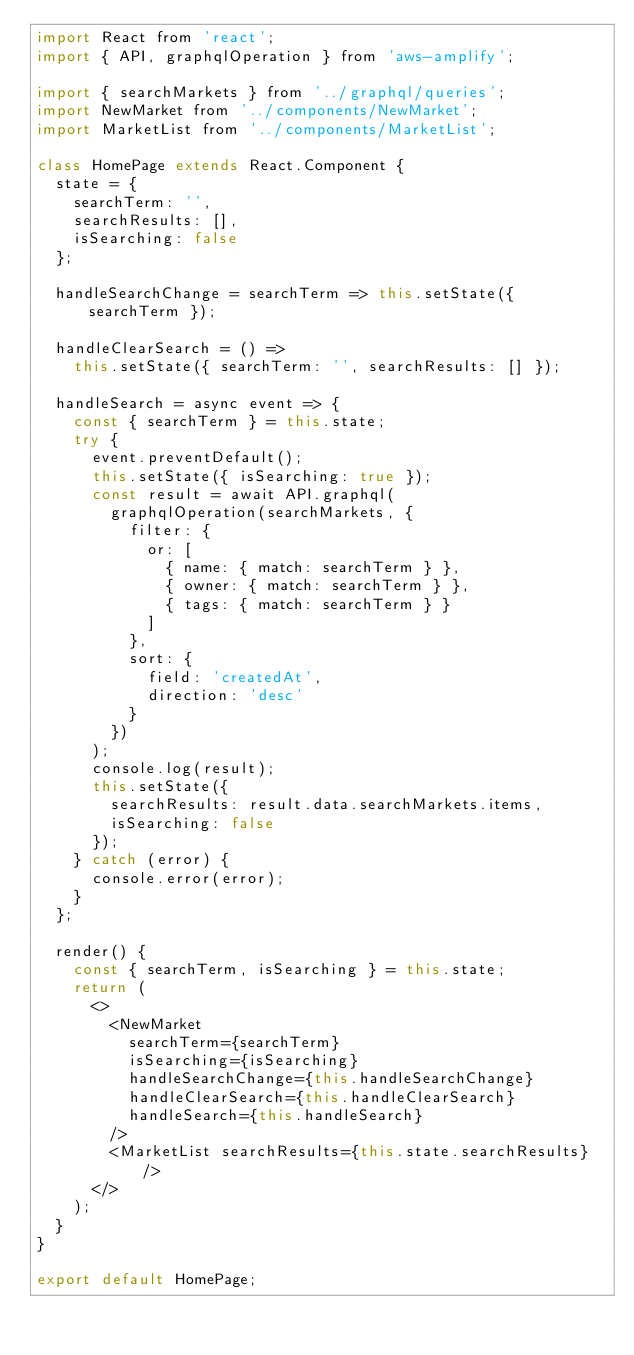<code> <loc_0><loc_0><loc_500><loc_500><_JavaScript_>import React from 'react';
import { API, graphqlOperation } from 'aws-amplify';

import { searchMarkets } from '../graphql/queries';
import NewMarket from '../components/NewMarket';
import MarketList from '../components/MarketList';

class HomePage extends React.Component {
  state = {
    searchTerm: '',
    searchResults: [],
    isSearching: false
  };

  handleSearchChange = searchTerm => this.setState({ searchTerm });

  handleClearSearch = () =>
    this.setState({ searchTerm: '', searchResults: [] });

  handleSearch = async event => {
    const { searchTerm } = this.state;
    try {
      event.preventDefault();
      this.setState({ isSearching: true });
      const result = await API.graphql(
        graphqlOperation(searchMarkets, {
          filter: {
            or: [
              { name: { match: searchTerm } },
              { owner: { match: searchTerm } },
              { tags: { match: searchTerm } }
            ]
          },
          sort: {
            field: 'createdAt',
            direction: 'desc'
          }
        })
      );
      console.log(result);
      this.setState({
        searchResults: result.data.searchMarkets.items,
        isSearching: false
      });
    } catch (error) {
      console.error(error);
    }
  };

  render() {
    const { searchTerm, isSearching } = this.state;
    return (
      <>
        <NewMarket
          searchTerm={searchTerm}
          isSearching={isSearching}
          handleSearchChange={this.handleSearchChange}
          handleClearSearch={this.handleClearSearch}
          handleSearch={this.handleSearch}
        />
        <MarketList searchResults={this.state.searchResults} />
      </>
    );
  }
}

export default HomePage;
</code> 